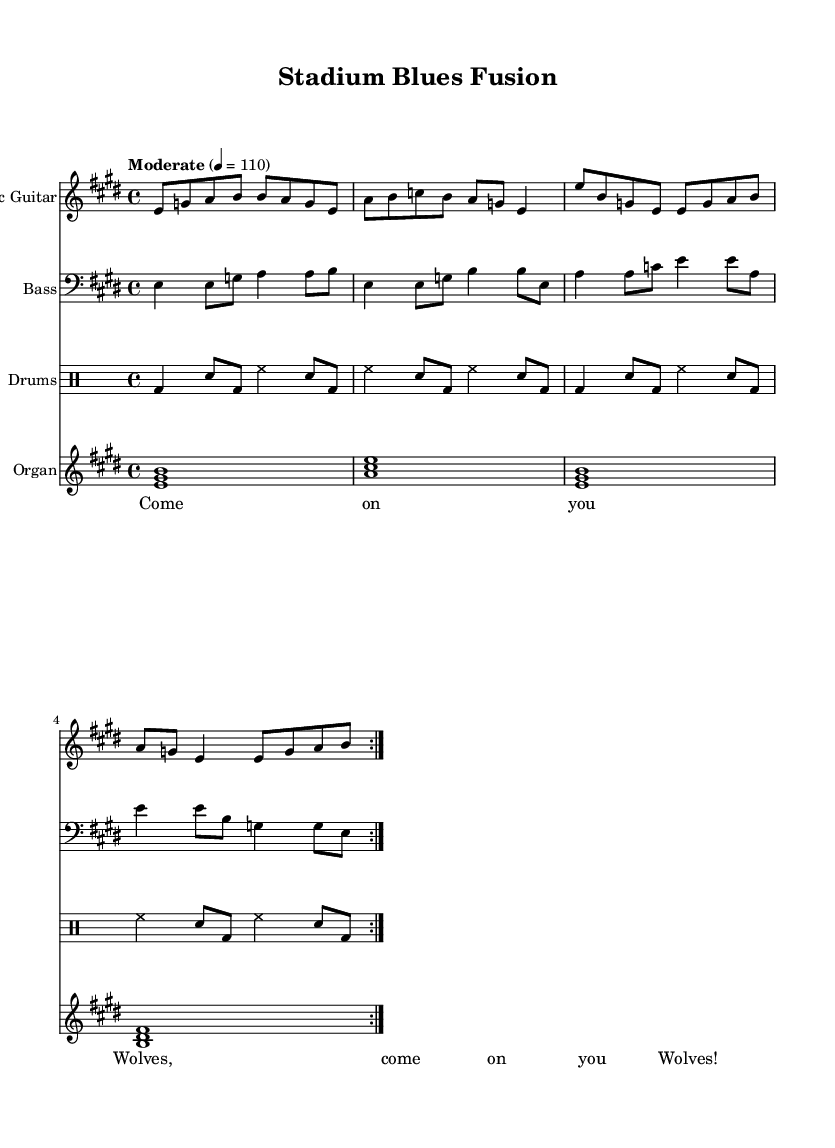What is the key signature of this music? The key signature is E major, which contains four sharps (F#, C#, G#, D#). This is determined by looking at the key noted at the beginning of the score, indicating the music is in E major.
Answer: E major What is the time signature of this music? The time signature is 4/4, which is noted at the beginning of the score. This means there are four beats in a measure, and the quarter note gets one beat.
Answer: 4/4 What is the tempo marking of this piece? The tempo marking indicates "Moderate" at a speed of 110 beats per minute. This information is typically found at the beginning of the score, which shows the intended speed of the music.
Answer: Moderate 4 = 110 How many times is the main theme repeated in this piece? The main theme is repeated two times, as indicated by the "volta" instructions in the measures for both the electric guitar and bass guitar parts. "Volta" indicates that the section will be played twice before moving on to the next section.
Answer: 2 Which instrument plays the crowd vocals? The crowd vocals are presented in the lyrics section, which indicates that they are sung by the audience, typically enhancing the atmosphere by incorporating football chants. The lyrics "Come on you Wolves" suggest a connection to the Wolverhampton football team.
Answer: Crowd Vocals What chords are played in the organ part during the first volta? The chords played in the organ part during the first volta are E major, A major, E major, and B major, which are notated in the score using the chord symbols at the beginning of each measure.
Answer: E major, A major, E major, B major What effect does the drum part create in this music? The drum part creates a driving rhythm, typically associated with a lively stadium atmosphere. The bass drum and snare patterns are repeated, which enhances the percussion-driven feel of the piece and supports the energy of the crowd chants.
Answer: Driving rhythm 